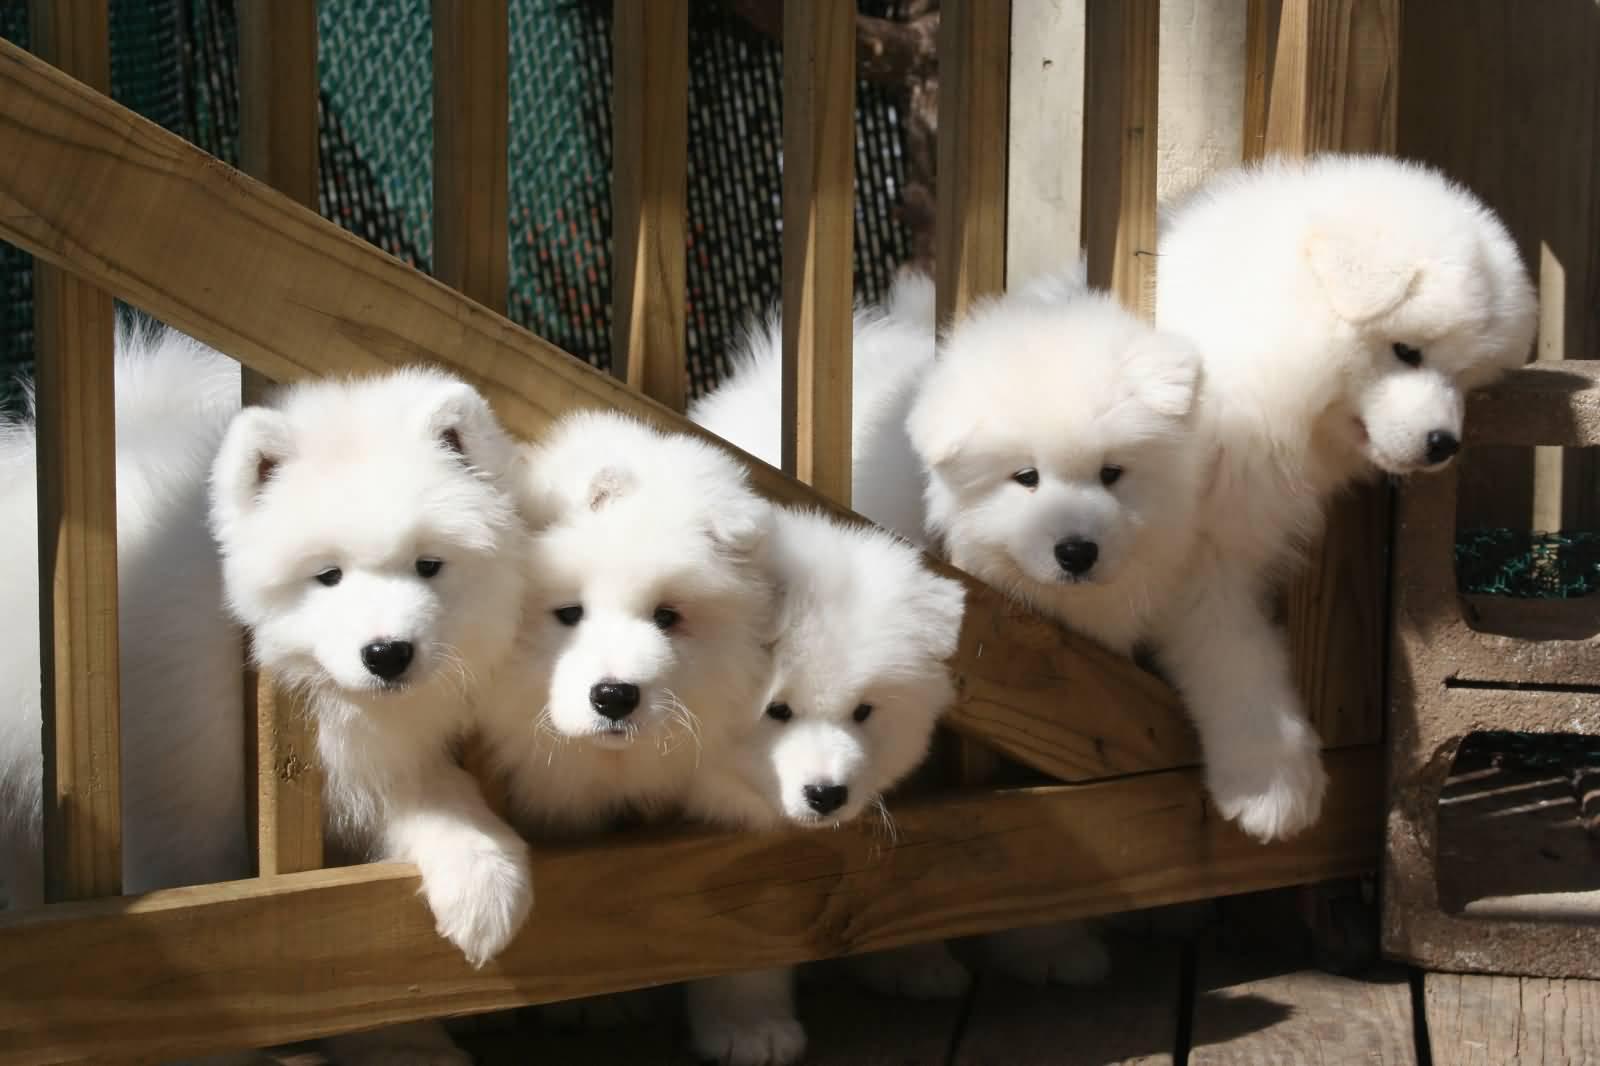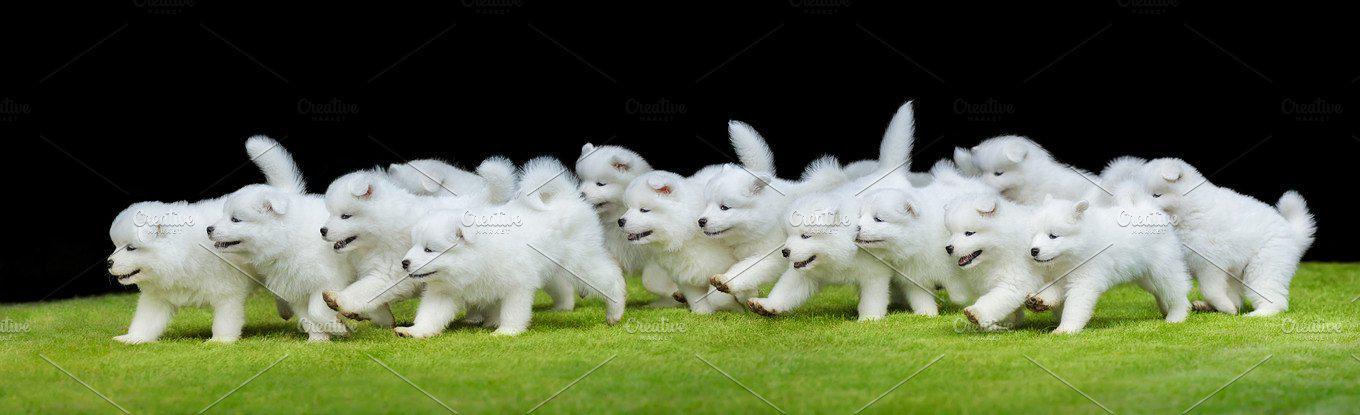The first image is the image on the left, the second image is the image on the right. Examine the images to the left and right. Is the description "An image shows at least one dog running toward the camera." accurate? Answer yes or no. No. 